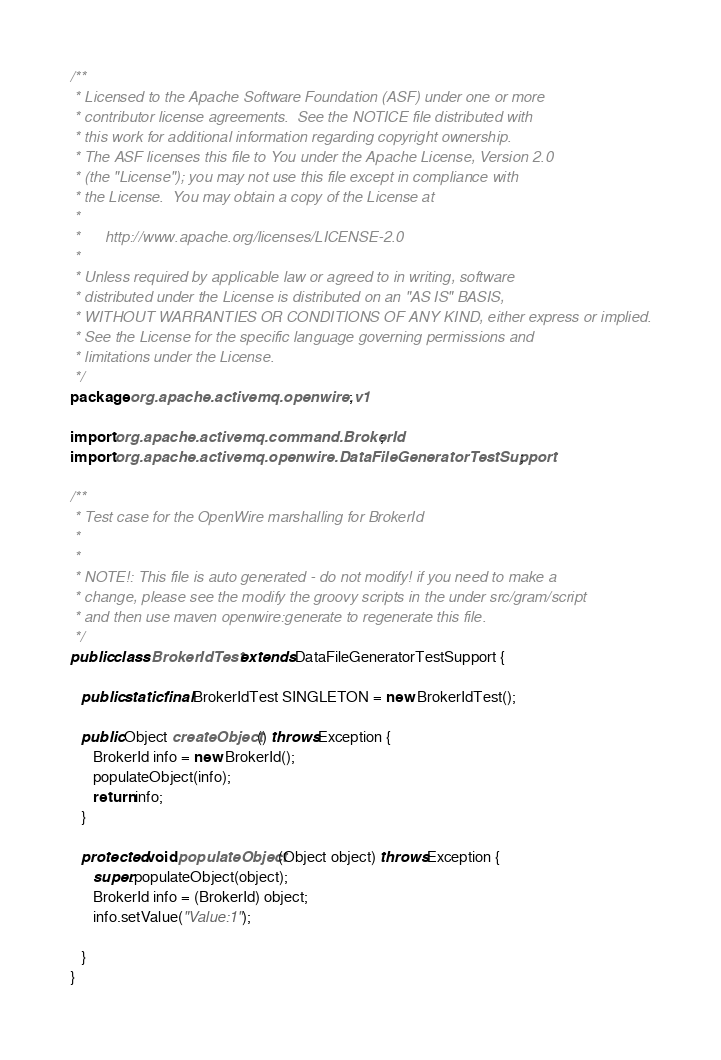Convert code to text. <code><loc_0><loc_0><loc_500><loc_500><_Java_>/**
 * Licensed to the Apache Software Foundation (ASF) under one or more
 * contributor license agreements.  See the NOTICE file distributed with
 * this work for additional information regarding copyright ownership.
 * The ASF licenses this file to You under the Apache License, Version 2.0
 * (the "License"); you may not use this file except in compliance with
 * the License.  You may obtain a copy of the License at
 *
 *      http://www.apache.org/licenses/LICENSE-2.0
 *
 * Unless required by applicable law or agreed to in writing, software
 * distributed under the License is distributed on an "AS IS" BASIS,
 * WITHOUT WARRANTIES OR CONDITIONS OF ANY KIND, either express or implied.
 * See the License for the specific language governing permissions and
 * limitations under the License.
 */
package org.apache.activemq.openwire.v1;

import org.apache.activemq.command.BrokerId;
import org.apache.activemq.openwire.DataFileGeneratorTestSupport;

/**
 * Test case for the OpenWire marshalling for BrokerId
 *
 *
 * NOTE!: This file is auto generated - do not modify! if you need to make a
 * change, please see the modify the groovy scripts in the under src/gram/script
 * and then use maven openwire:generate to regenerate this file.
 */
public class BrokerIdTest extends DataFileGeneratorTestSupport {

   public static final BrokerIdTest SINGLETON = new BrokerIdTest();

   public Object createObject() throws Exception {
      BrokerId info = new BrokerId();
      populateObject(info);
      return info;
   }

   protected void populateObject(Object object) throws Exception {
      super.populateObject(object);
      BrokerId info = (BrokerId) object;
      info.setValue("Value:1");

   }
}
</code> 